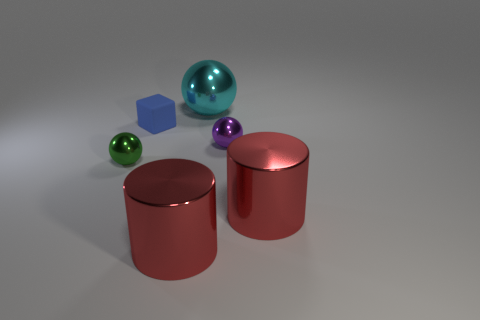Are any big gray spheres visible?
Give a very brief answer. No. Is there anything else that has the same shape as the tiny rubber thing?
Offer a very short reply. No. What number of objects are either small objects in front of the rubber cube or big shiny things?
Your response must be concise. 5. What number of blue matte cubes are left of the object that is in front of the cylinder on the right side of the large cyan shiny sphere?
Your response must be concise. 1. What shape is the small shiny thing that is behind the tiny sphere in front of the sphere on the right side of the big cyan shiny object?
Offer a very short reply. Sphere. How many other things are the same color as the big metallic sphere?
Ensure brevity in your answer.  0. There is a large object behind the small ball to the left of the blue object; what shape is it?
Keep it short and to the point. Sphere. There is a small rubber block; what number of big red objects are behind it?
Keep it short and to the point. 0. Is there a large red object made of the same material as the small green thing?
Offer a very short reply. Yes. There is a purple thing that is the same size as the green shiny ball; what is its material?
Offer a terse response. Metal. 